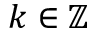<formula> <loc_0><loc_0><loc_500><loc_500>k \in \mathbb { Z }</formula> 